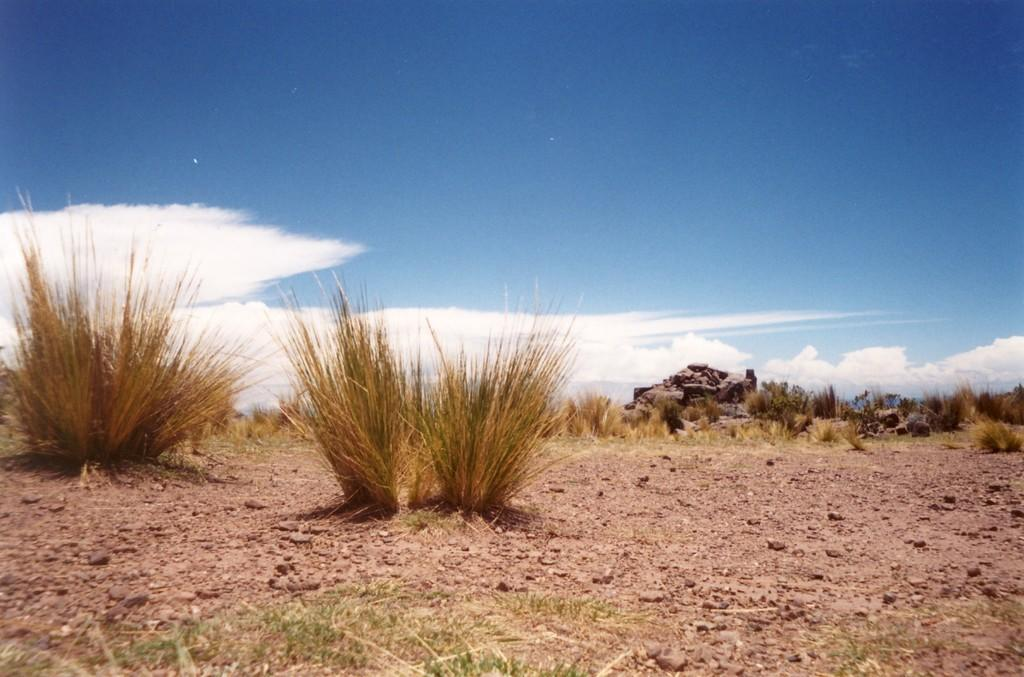What type of surface is visible in the image? There is ground visible in the image. What type of vegetation can be seen on the ground? There is grass in the image. What other objects are present on the ground? There are stones in the image. What is visible in the background of the image? The sky is visible in the background of the image. What can be seen in the sky? There are clouds in the sky. What type of toothpaste is being used to clean the stones in the image? There is no toothpaste or cleaning activity present in the image. The stones are simply visible on the ground. 